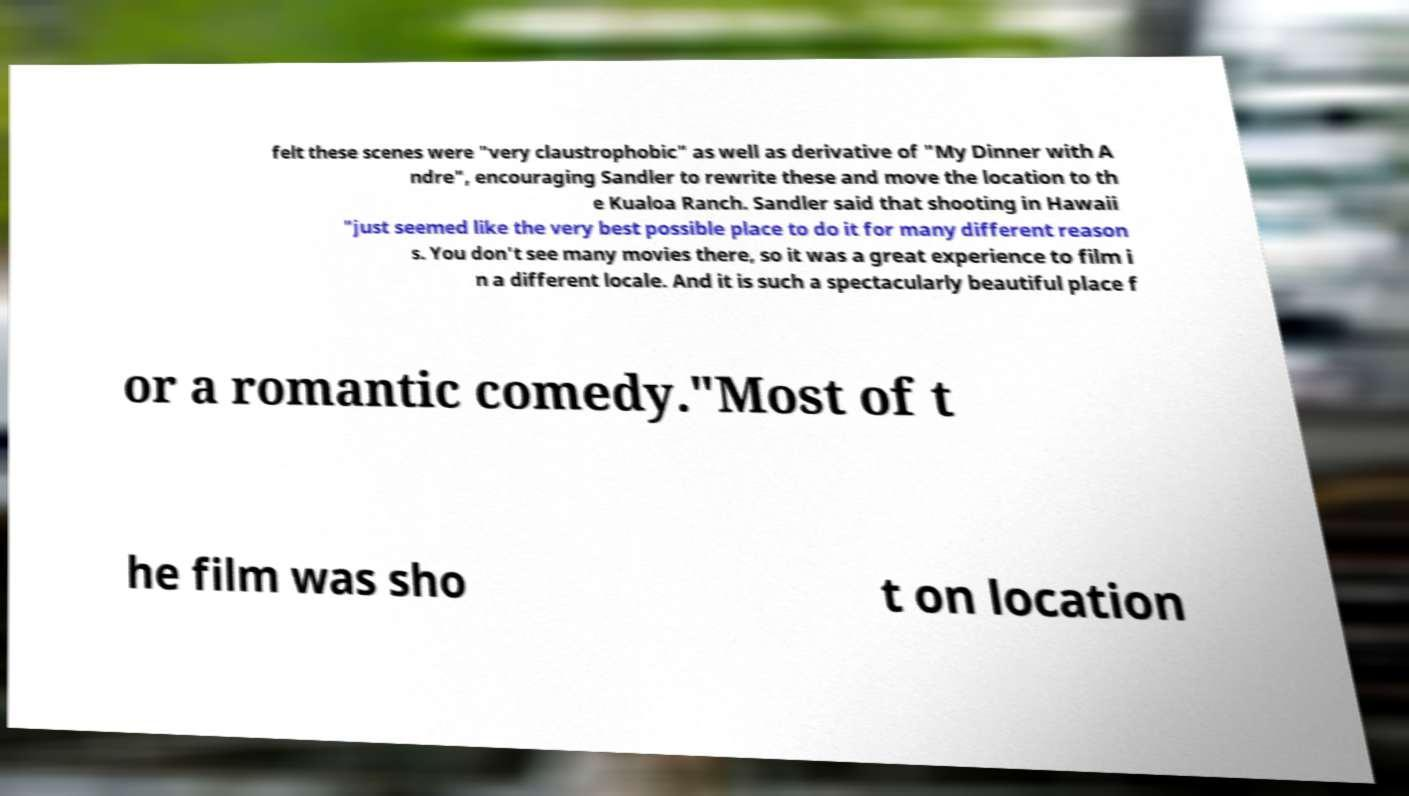There's text embedded in this image that I need extracted. Can you transcribe it verbatim? felt these scenes were "very claustrophobic" as well as derivative of "My Dinner with A ndre", encouraging Sandler to rewrite these and move the location to th e Kualoa Ranch. Sandler said that shooting in Hawaii "just seemed like the very best possible place to do it for many different reason s. You don't see many movies there, so it was a great experience to film i n a different locale. And it is such a spectacularly beautiful place f or a romantic comedy."Most of t he film was sho t on location 